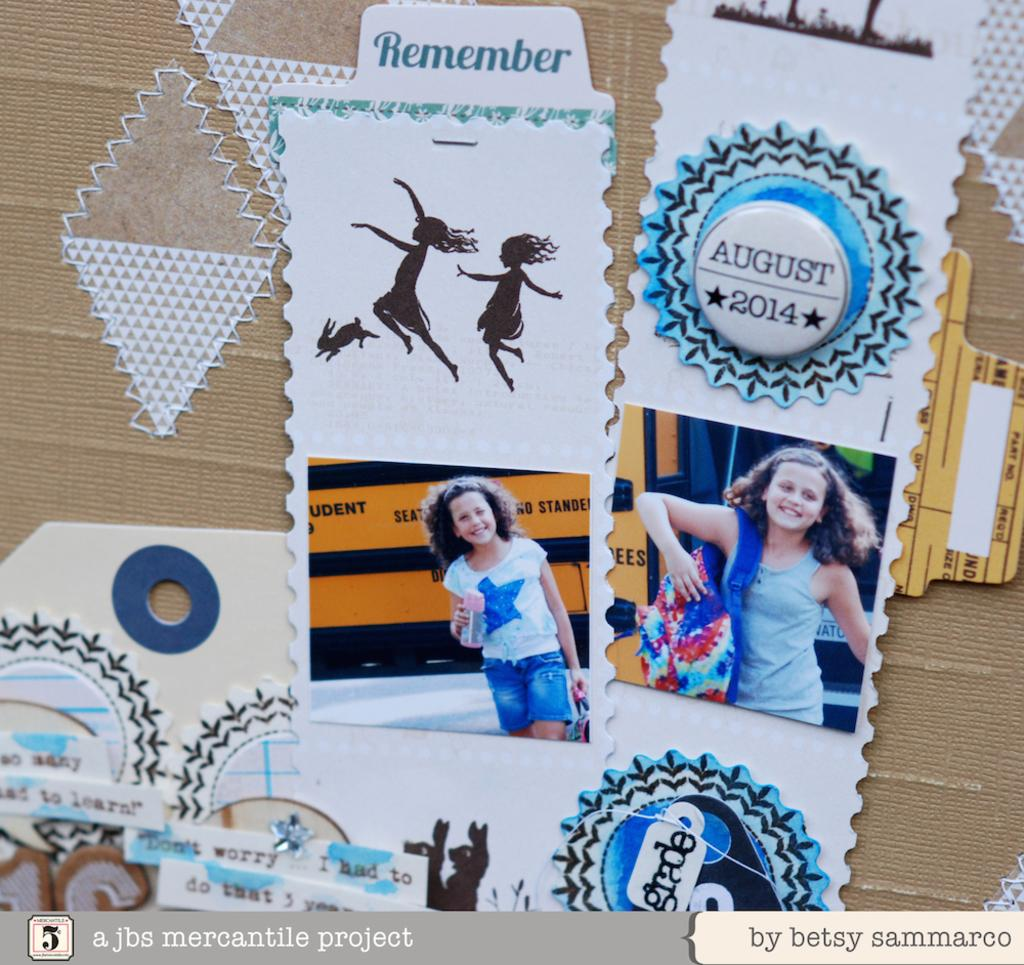What can be seen in the image? There are posts in the image. What is on the posts? There are posters with images of women on the posts. What type of turkey can be seen grazing in the field in the image? There is no turkey or field present in the image; it only features posts with posters of women. 